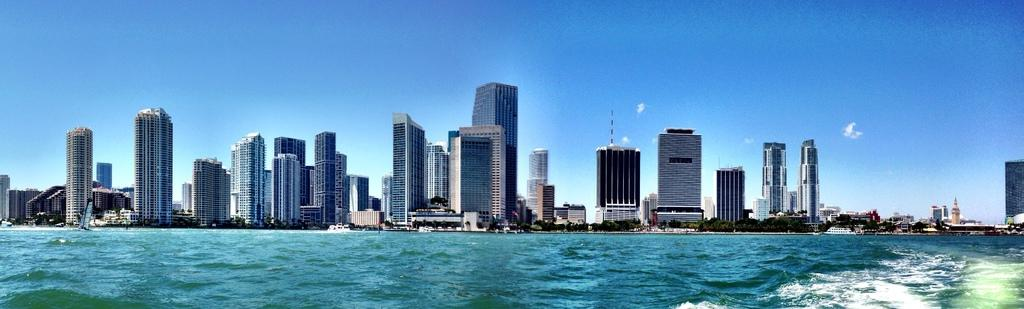What is present at the bottom of the image? There is water at the bottom of the image. What can be seen in the distance in the image? There are buildings and trees in the background of the image. What is visible in the sky in the image? The sky is visible in the background of the image. What flavor of ice cream is being served in the park in the image? There is no ice cream or park present in the image; it features water, buildings, trees, and the sky. 